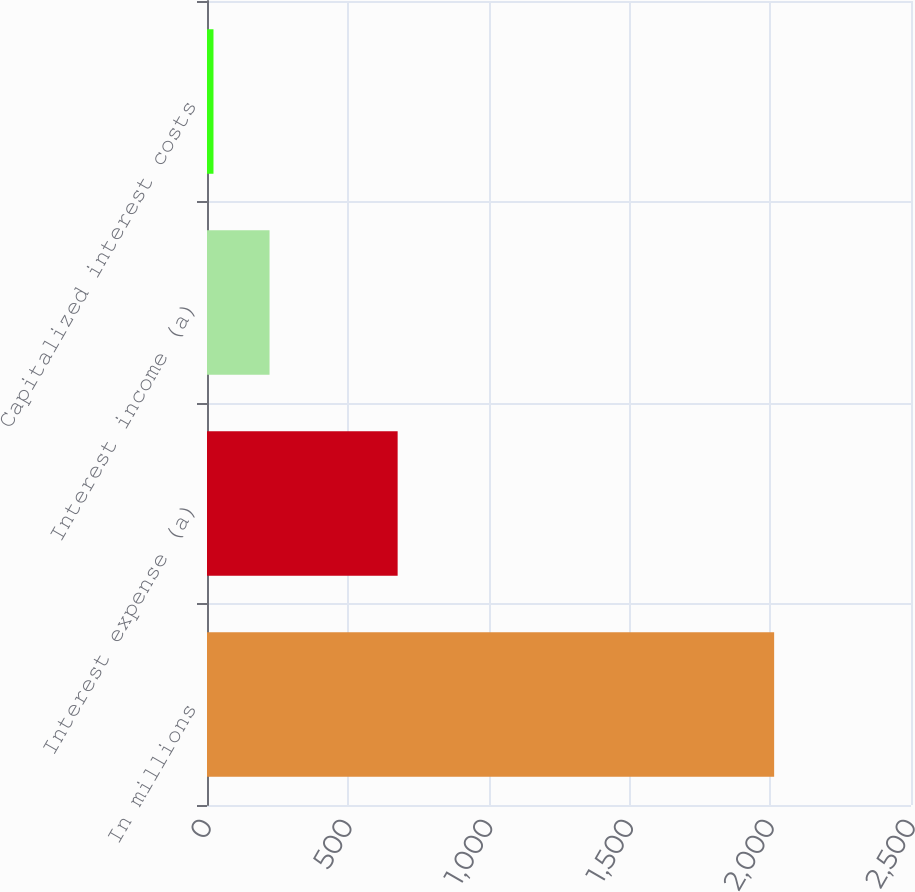<chart> <loc_0><loc_0><loc_500><loc_500><bar_chart><fcel>In millions<fcel>Interest expense (a)<fcel>Interest income (a)<fcel>Capitalized interest costs<nl><fcel>2014<fcel>677<fcel>222.1<fcel>23<nl></chart> 